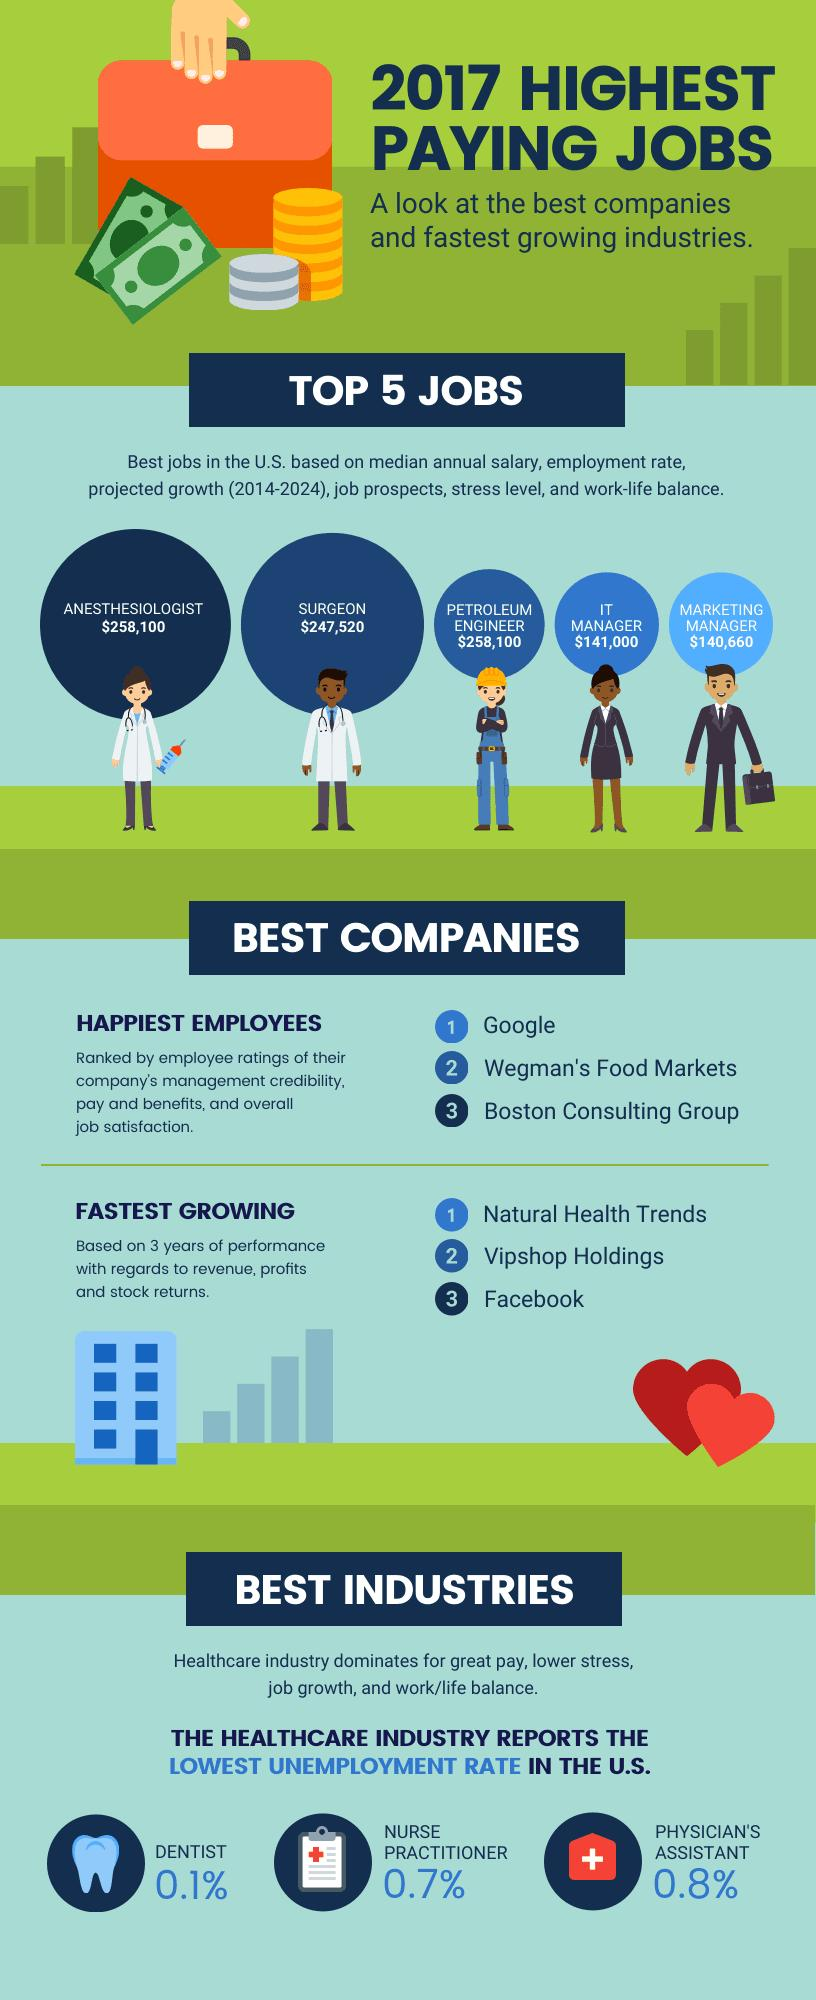Give some essential details in this illustration. The median annual salary of a surgeon in the United States is $247,520. A petroleum engineer earns the same salary as an anesthesiologist. According to a recent ranking, Boston Consulting Group is ranked third in the category of companies with the happiest employees. In the image, Facebook is listed third in the category of companies with the fastest growth. According to the information provided, the median annual salary of the fourth job listed among the top 5 jobs in the United States is $141,000. 